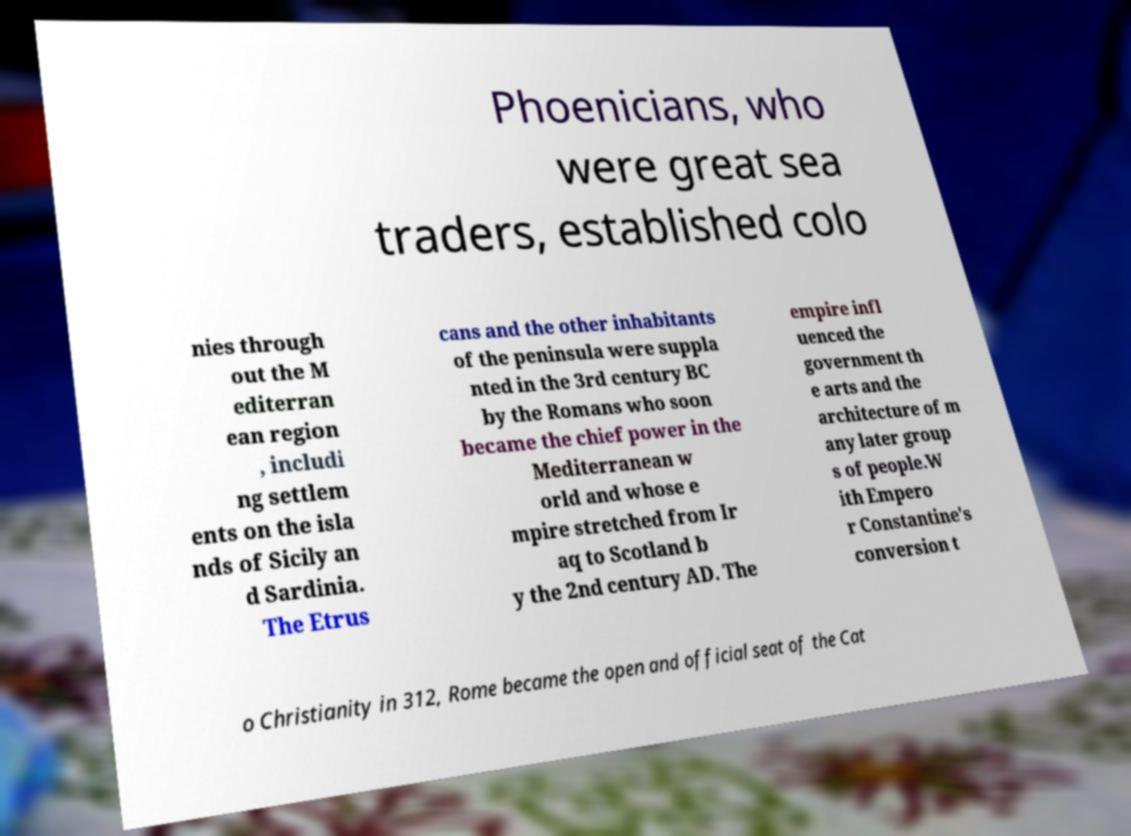For documentation purposes, I need the text within this image transcribed. Could you provide that? Phoenicians, who were great sea traders, established colo nies through out the M editerran ean region , includi ng settlem ents on the isla nds of Sicily an d Sardinia. The Etrus cans and the other inhabitants of the peninsula were suppla nted in the 3rd century BC by the Romans who soon became the chief power in the Mediterranean w orld and whose e mpire stretched from Ir aq to Scotland b y the 2nd century AD. The empire infl uenced the government th e arts and the architecture of m any later group s of people.W ith Empero r Constantine's conversion t o Christianity in 312, Rome became the open and official seat of the Cat 